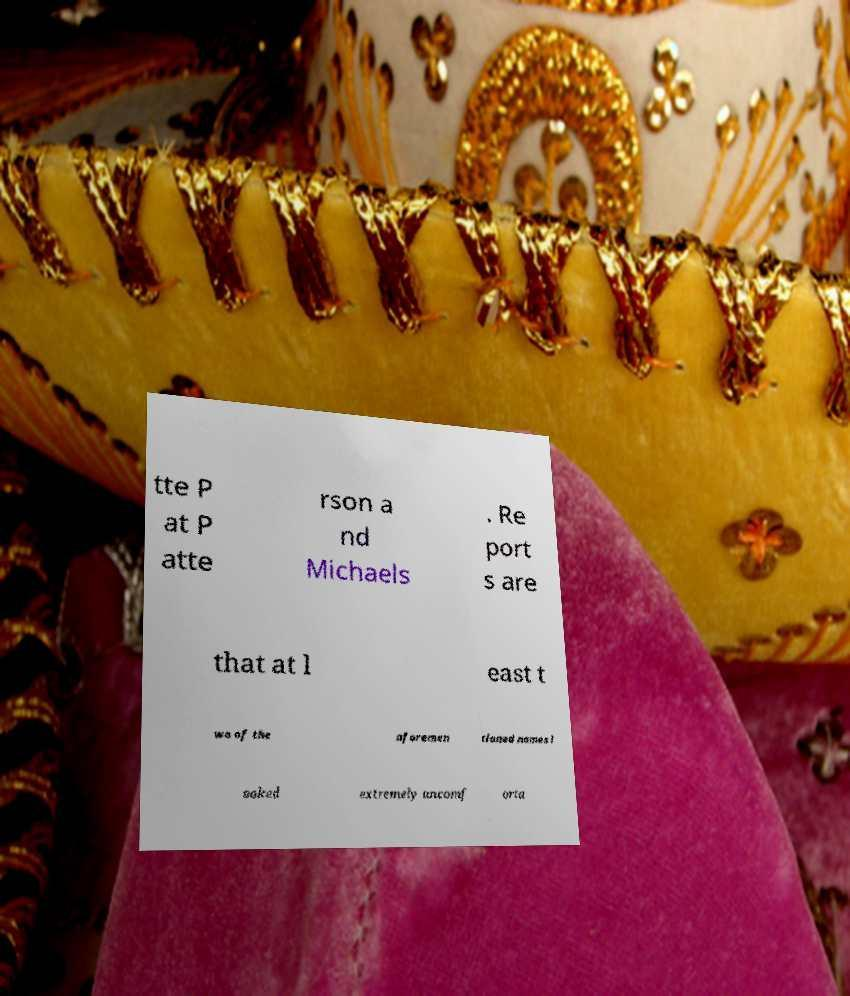Can you read and provide the text displayed in the image?This photo seems to have some interesting text. Can you extract and type it out for me? tte P at P atte rson a nd Michaels . Re port s are that at l east t wo of the aforemen tioned names l ooked extremely uncomf orta 